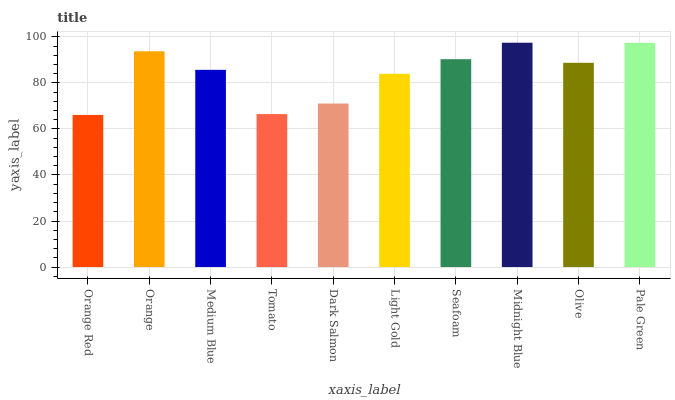Is Orange Red the minimum?
Answer yes or no. Yes. Is Midnight Blue the maximum?
Answer yes or no. Yes. Is Orange the minimum?
Answer yes or no. No. Is Orange the maximum?
Answer yes or no. No. Is Orange greater than Orange Red?
Answer yes or no. Yes. Is Orange Red less than Orange?
Answer yes or no. Yes. Is Orange Red greater than Orange?
Answer yes or no. No. Is Orange less than Orange Red?
Answer yes or no. No. Is Olive the high median?
Answer yes or no. Yes. Is Medium Blue the low median?
Answer yes or no. Yes. Is Dark Salmon the high median?
Answer yes or no. No. Is Pale Green the low median?
Answer yes or no. No. 